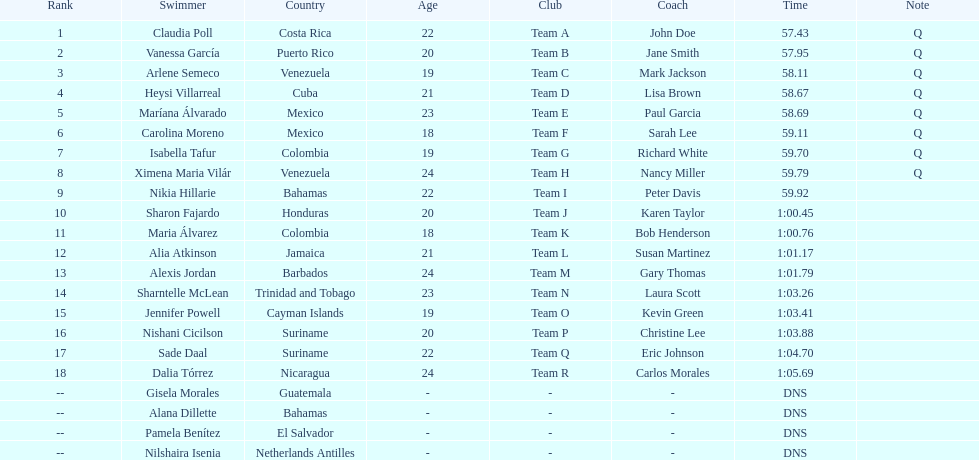Who was the last competitor to actually finish the preliminaries? Dalia Tórrez. 